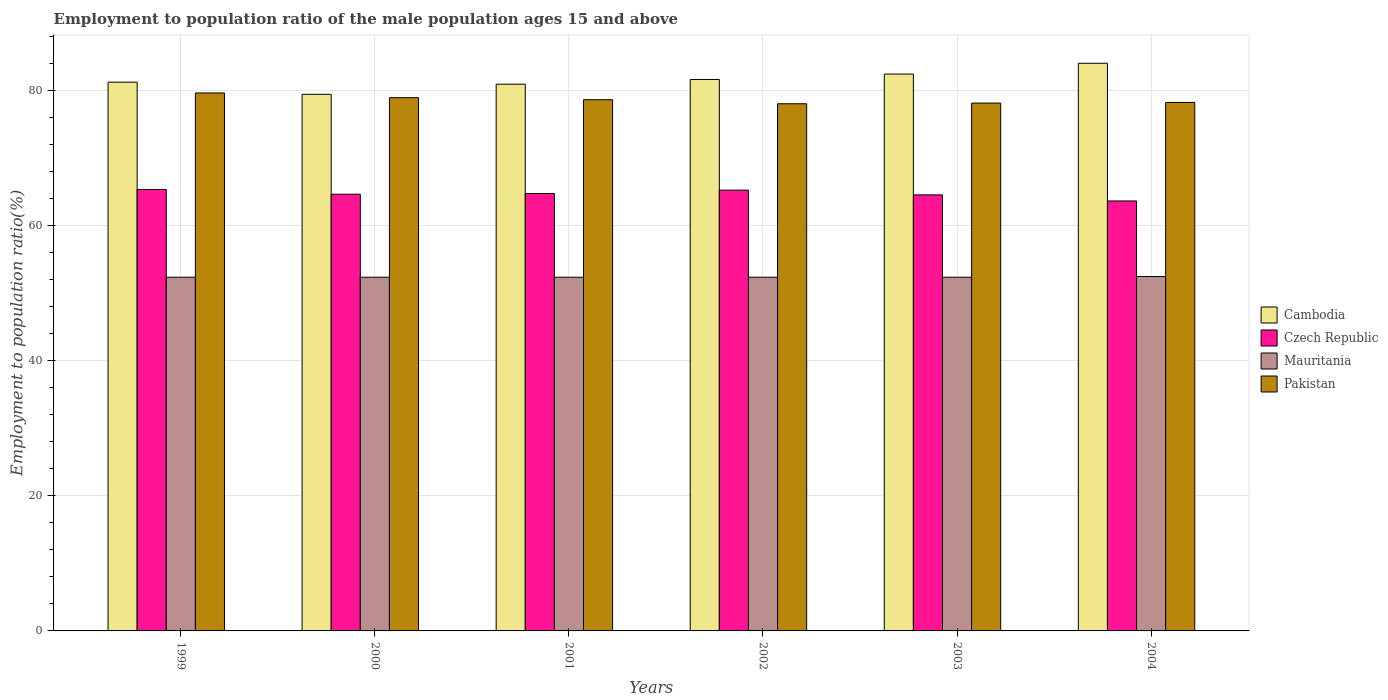Are the number of bars per tick equal to the number of legend labels?
Your answer should be compact. Yes. How many bars are there on the 4th tick from the left?
Your answer should be very brief. 4. In how many cases, is the number of bars for a given year not equal to the number of legend labels?
Give a very brief answer. 0. What is the employment to population ratio in Czech Republic in 2004?
Provide a short and direct response. 63.7. Across all years, what is the maximum employment to population ratio in Mauritania?
Offer a terse response. 52.5. Across all years, what is the minimum employment to population ratio in Cambodia?
Ensure brevity in your answer.  79.5. In which year was the employment to population ratio in Cambodia minimum?
Your response must be concise. 2000. What is the total employment to population ratio in Czech Republic in the graph?
Your answer should be compact. 388.5. What is the difference between the employment to population ratio in Cambodia in 2000 and that in 2003?
Keep it short and to the point. -3. What is the difference between the employment to population ratio in Mauritania in 2002 and the employment to population ratio in Cambodia in 1999?
Give a very brief answer. -28.9. What is the average employment to population ratio in Pakistan per year?
Your response must be concise. 78.67. In the year 2001, what is the difference between the employment to population ratio in Pakistan and employment to population ratio in Czech Republic?
Provide a succinct answer. 13.9. What is the ratio of the employment to population ratio in Czech Republic in 1999 to that in 2000?
Ensure brevity in your answer.  1.01. What is the difference between the highest and the second highest employment to population ratio in Cambodia?
Make the answer very short. 1.6. What is the difference between the highest and the lowest employment to population ratio in Pakistan?
Ensure brevity in your answer.  1.6. In how many years, is the employment to population ratio in Czech Republic greater than the average employment to population ratio in Czech Republic taken over all years?
Provide a succinct answer. 3. Is it the case that in every year, the sum of the employment to population ratio in Mauritania and employment to population ratio in Cambodia is greater than the sum of employment to population ratio in Pakistan and employment to population ratio in Czech Republic?
Your answer should be compact. Yes. What does the 1st bar from the left in 2004 represents?
Offer a terse response. Cambodia. What does the 2nd bar from the right in 1999 represents?
Your response must be concise. Mauritania. Is it the case that in every year, the sum of the employment to population ratio in Cambodia and employment to population ratio in Pakistan is greater than the employment to population ratio in Czech Republic?
Your answer should be compact. Yes. Are all the bars in the graph horizontal?
Provide a succinct answer. No. How many years are there in the graph?
Keep it short and to the point. 6. How are the legend labels stacked?
Make the answer very short. Vertical. What is the title of the graph?
Make the answer very short. Employment to population ratio of the male population ages 15 and above. What is the label or title of the Y-axis?
Offer a very short reply. Employment to population ratio(%). What is the Employment to population ratio(%) of Cambodia in 1999?
Your response must be concise. 81.3. What is the Employment to population ratio(%) of Czech Republic in 1999?
Make the answer very short. 65.4. What is the Employment to population ratio(%) of Mauritania in 1999?
Provide a succinct answer. 52.4. What is the Employment to population ratio(%) of Pakistan in 1999?
Keep it short and to the point. 79.7. What is the Employment to population ratio(%) of Cambodia in 2000?
Keep it short and to the point. 79.5. What is the Employment to population ratio(%) in Czech Republic in 2000?
Ensure brevity in your answer.  64.7. What is the Employment to population ratio(%) in Mauritania in 2000?
Provide a short and direct response. 52.4. What is the Employment to population ratio(%) of Pakistan in 2000?
Offer a terse response. 79. What is the Employment to population ratio(%) of Czech Republic in 2001?
Make the answer very short. 64.8. What is the Employment to population ratio(%) in Mauritania in 2001?
Your answer should be very brief. 52.4. What is the Employment to population ratio(%) of Pakistan in 2001?
Make the answer very short. 78.7. What is the Employment to population ratio(%) in Cambodia in 2002?
Your answer should be compact. 81.7. What is the Employment to population ratio(%) of Czech Republic in 2002?
Your response must be concise. 65.3. What is the Employment to population ratio(%) in Mauritania in 2002?
Your answer should be compact. 52.4. What is the Employment to population ratio(%) of Pakistan in 2002?
Ensure brevity in your answer.  78.1. What is the Employment to population ratio(%) of Cambodia in 2003?
Make the answer very short. 82.5. What is the Employment to population ratio(%) in Czech Republic in 2003?
Provide a succinct answer. 64.6. What is the Employment to population ratio(%) in Mauritania in 2003?
Provide a succinct answer. 52.4. What is the Employment to population ratio(%) of Pakistan in 2003?
Offer a terse response. 78.2. What is the Employment to population ratio(%) of Cambodia in 2004?
Provide a short and direct response. 84.1. What is the Employment to population ratio(%) in Czech Republic in 2004?
Your answer should be compact. 63.7. What is the Employment to population ratio(%) of Mauritania in 2004?
Keep it short and to the point. 52.5. What is the Employment to population ratio(%) in Pakistan in 2004?
Give a very brief answer. 78.3. Across all years, what is the maximum Employment to population ratio(%) of Cambodia?
Make the answer very short. 84.1. Across all years, what is the maximum Employment to population ratio(%) of Czech Republic?
Give a very brief answer. 65.4. Across all years, what is the maximum Employment to population ratio(%) of Mauritania?
Your answer should be compact. 52.5. Across all years, what is the maximum Employment to population ratio(%) in Pakistan?
Ensure brevity in your answer.  79.7. Across all years, what is the minimum Employment to population ratio(%) of Cambodia?
Your response must be concise. 79.5. Across all years, what is the minimum Employment to population ratio(%) of Czech Republic?
Your response must be concise. 63.7. Across all years, what is the minimum Employment to population ratio(%) of Mauritania?
Your answer should be very brief. 52.4. Across all years, what is the minimum Employment to population ratio(%) in Pakistan?
Offer a very short reply. 78.1. What is the total Employment to population ratio(%) in Cambodia in the graph?
Provide a succinct answer. 490.1. What is the total Employment to population ratio(%) of Czech Republic in the graph?
Make the answer very short. 388.5. What is the total Employment to population ratio(%) of Mauritania in the graph?
Offer a very short reply. 314.5. What is the total Employment to population ratio(%) in Pakistan in the graph?
Your response must be concise. 472. What is the difference between the Employment to population ratio(%) of Cambodia in 1999 and that in 2000?
Your response must be concise. 1.8. What is the difference between the Employment to population ratio(%) of Czech Republic in 1999 and that in 2000?
Give a very brief answer. 0.7. What is the difference between the Employment to population ratio(%) in Czech Republic in 1999 and that in 2002?
Ensure brevity in your answer.  0.1. What is the difference between the Employment to population ratio(%) of Mauritania in 1999 and that in 2002?
Make the answer very short. 0. What is the difference between the Employment to population ratio(%) in Pakistan in 1999 and that in 2002?
Your answer should be compact. 1.6. What is the difference between the Employment to population ratio(%) in Cambodia in 1999 and that in 2003?
Ensure brevity in your answer.  -1.2. What is the difference between the Employment to population ratio(%) of Cambodia in 1999 and that in 2004?
Your response must be concise. -2.8. What is the difference between the Employment to population ratio(%) in Cambodia in 2000 and that in 2001?
Offer a terse response. -1.5. What is the difference between the Employment to population ratio(%) of Czech Republic in 2000 and that in 2001?
Give a very brief answer. -0.1. What is the difference between the Employment to population ratio(%) of Mauritania in 2000 and that in 2001?
Your answer should be very brief. 0. What is the difference between the Employment to population ratio(%) in Czech Republic in 2000 and that in 2002?
Keep it short and to the point. -0.6. What is the difference between the Employment to population ratio(%) of Cambodia in 2000 and that in 2003?
Your answer should be compact. -3. What is the difference between the Employment to population ratio(%) in Pakistan in 2000 and that in 2003?
Offer a terse response. 0.8. What is the difference between the Employment to population ratio(%) in Pakistan in 2000 and that in 2004?
Offer a terse response. 0.7. What is the difference between the Employment to population ratio(%) of Pakistan in 2001 and that in 2002?
Keep it short and to the point. 0.6. What is the difference between the Employment to population ratio(%) of Cambodia in 2001 and that in 2003?
Your response must be concise. -1.5. What is the difference between the Employment to population ratio(%) in Czech Republic in 2001 and that in 2003?
Offer a terse response. 0.2. What is the difference between the Employment to population ratio(%) of Mauritania in 2001 and that in 2003?
Keep it short and to the point. 0. What is the difference between the Employment to population ratio(%) in Cambodia in 2001 and that in 2004?
Offer a terse response. -3.1. What is the difference between the Employment to population ratio(%) of Czech Republic in 2001 and that in 2004?
Provide a short and direct response. 1.1. What is the difference between the Employment to population ratio(%) in Cambodia in 2002 and that in 2003?
Your answer should be very brief. -0.8. What is the difference between the Employment to population ratio(%) in Czech Republic in 2002 and that in 2003?
Provide a succinct answer. 0.7. What is the difference between the Employment to population ratio(%) in Cambodia in 2003 and that in 2004?
Give a very brief answer. -1.6. What is the difference between the Employment to population ratio(%) in Czech Republic in 2003 and that in 2004?
Your response must be concise. 0.9. What is the difference between the Employment to population ratio(%) of Mauritania in 2003 and that in 2004?
Offer a very short reply. -0.1. What is the difference between the Employment to population ratio(%) in Cambodia in 1999 and the Employment to population ratio(%) in Mauritania in 2000?
Make the answer very short. 28.9. What is the difference between the Employment to population ratio(%) in Cambodia in 1999 and the Employment to population ratio(%) in Pakistan in 2000?
Give a very brief answer. 2.3. What is the difference between the Employment to population ratio(%) of Czech Republic in 1999 and the Employment to population ratio(%) of Pakistan in 2000?
Offer a terse response. -13.6. What is the difference between the Employment to population ratio(%) of Mauritania in 1999 and the Employment to population ratio(%) of Pakistan in 2000?
Your answer should be compact. -26.6. What is the difference between the Employment to population ratio(%) of Cambodia in 1999 and the Employment to population ratio(%) of Mauritania in 2001?
Keep it short and to the point. 28.9. What is the difference between the Employment to population ratio(%) of Czech Republic in 1999 and the Employment to population ratio(%) of Mauritania in 2001?
Make the answer very short. 13. What is the difference between the Employment to population ratio(%) of Czech Republic in 1999 and the Employment to population ratio(%) of Pakistan in 2001?
Provide a short and direct response. -13.3. What is the difference between the Employment to population ratio(%) in Mauritania in 1999 and the Employment to population ratio(%) in Pakistan in 2001?
Give a very brief answer. -26.3. What is the difference between the Employment to population ratio(%) in Cambodia in 1999 and the Employment to population ratio(%) in Czech Republic in 2002?
Your response must be concise. 16. What is the difference between the Employment to population ratio(%) of Cambodia in 1999 and the Employment to population ratio(%) of Mauritania in 2002?
Offer a terse response. 28.9. What is the difference between the Employment to population ratio(%) in Mauritania in 1999 and the Employment to population ratio(%) in Pakistan in 2002?
Provide a succinct answer. -25.7. What is the difference between the Employment to population ratio(%) of Cambodia in 1999 and the Employment to population ratio(%) of Mauritania in 2003?
Provide a short and direct response. 28.9. What is the difference between the Employment to population ratio(%) in Cambodia in 1999 and the Employment to population ratio(%) in Pakistan in 2003?
Ensure brevity in your answer.  3.1. What is the difference between the Employment to population ratio(%) in Czech Republic in 1999 and the Employment to population ratio(%) in Mauritania in 2003?
Your response must be concise. 13. What is the difference between the Employment to population ratio(%) of Czech Republic in 1999 and the Employment to population ratio(%) of Pakistan in 2003?
Provide a succinct answer. -12.8. What is the difference between the Employment to population ratio(%) of Mauritania in 1999 and the Employment to population ratio(%) of Pakistan in 2003?
Provide a short and direct response. -25.8. What is the difference between the Employment to population ratio(%) in Cambodia in 1999 and the Employment to population ratio(%) in Czech Republic in 2004?
Your answer should be very brief. 17.6. What is the difference between the Employment to population ratio(%) in Cambodia in 1999 and the Employment to population ratio(%) in Mauritania in 2004?
Your response must be concise. 28.8. What is the difference between the Employment to population ratio(%) of Czech Republic in 1999 and the Employment to population ratio(%) of Mauritania in 2004?
Your response must be concise. 12.9. What is the difference between the Employment to population ratio(%) of Czech Republic in 1999 and the Employment to population ratio(%) of Pakistan in 2004?
Give a very brief answer. -12.9. What is the difference between the Employment to population ratio(%) in Mauritania in 1999 and the Employment to population ratio(%) in Pakistan in 2004?
Make the answer very short. -25.9. What is the difference between the Employment to population ratio(%) in Cambodia in 2000 and the Employment to population ratio(%) in Czech Republic in 2001?
Provide a short and direct response. 14.7. What is the difference between the Employment to population ratio(%) in Cambodia in 2000 and the Employment to population ratio(%) in Mauritania in 2001?
Give a very brief answer. 27.1. What is the difference between the Employment to population ratio(%) in Mauritania in 2000 and the Employment to population ratio(%) in Pakistan in 2001?
Provide a short and direct response. -26.3. What is the difference between the Employment to population ratio(%) of Cambodia in 2000 and the Employment to population ratio(%) of Mauritania in 2002?
Provide a succinct answer. 27.1. What is the difference between the Employment to population ratio(%) of Cambodia in 2000 and the Employment to population ratio(%) of Pakistan in 2002?
Your answer should be very brief. 1.4. What is the difference between the Employment to population ratio(%) in Czech Republic in 2000 and the Employment to population ratio(%) in Mauritania in 2002?
Your response must be concise. 12.3. What is the difference between the Employment to population ratio(%) of Mauritania in 2000 and the Employment to population ratio(%) of Pakistan in 2002?
Offer a terse response. -25.7. What is the difference between the Employment to population ratio(%) of Cambodia in 2000 and the Employment to population ratio(%) of Czech Republic in 2003?
Offer a very short reply. 14.9. What is the difference between the Employment to population ratio(%) of Cambodia in 2000 and the Employment to population ratio(%) of Mauritania in 2003?
Make the answer very short. 27.1. What is the difference between the Employment to population ratio(%) in Cambodia in 2000 and the Employment to population ratio(%) in Pakistan in 2003?
Provide a succinct answer. 1.3. What is the difference between the Employment to population ratio(%) in Mauritania in 2000 and the Employment to population ratio(%) in Pakistan in 2003?
Your response must be concise. -25.8. What is the difference between the Employment to population ratio(%) of Cambodia in 2000 and the Employment to population ratio(%) of Czech Republic in 2004?
Provide a short and direct response. 15.8. What is the difference between the Employment to population ratio(%) in Czech Republic in 2000 and the Employment to population ratio(%) in Mauritania in 2004?
Your answer should be very brief. 12.2. What is the difference between the Employment to population ratio(%) of Mauritania in 2000 and the Employment to population ratio(%) of Pakistan in 2004?
Your answer should be compact. -25.9. What is the difference between the Employment to population ratio(%) of Cambodia in 2001 and the Employment to population ratio(%) of Czech Republic in 2002?
Your answer should be very brief. 15.7. What is the difference between the Employment to population ratio(%) of Cambodia in 2001 and the Employment to population ratio(%) of Mauritania in 2002?
Your answer should be compact. 28.6. What is the difference between the Employment to population ratio(%) of Cambodia in 2001 and the Employment to population ratio(%) of Pakistan in 2002?
Provide a succinct answer. 2.9. What is the difference between the Employment to population ratio(%) of Czech Republic in 2001 and the Employment to population ratio(%) of Pakistan in 2002?
Provide a succinct answer. -13.3. What is the difference between the Employment to population ratio(%) in Mauritania in 2001 and the Employment to population ratio(%) in Pakistan in 2002?
Your response must be concise. -25.7. What is the difference between the Employment to population ratio(%) in Cambodia in 2001 and the Employment to population ratio(%) in Czech Republic in 2003?
Make the answer very short. 16.4. What is the difference between the Employment to population ratio(%) of Cambodia in 2001 and the Employment to population ratio(%) of Mauritania in 2003?
Provide a succinct answer. 28.6. What is the difference between the Employment to population ratio(%) of Cambodia in 2001 and the Employment to population ratio(%) of Pakistan in 2003?
Provide a short and direct response. 2.8. What is the difference between the Employment to population ratio(%) of Czech Republic in 2001 and the Employment to population ratio(%) of Pakistan in 2003?
Provide a succinct answer. -13.4. What is the difference between the Employment to population ratio(%) of Mauritania in 2001 and the Employment to population ratio(%) of Pakistan in 2003?
Give a very brief answer. -25.8. What is the difference between the Employment to population ratio(%) of Cambodia in 2001 and the Employment to population ratio(%) of Czech Republic in 2004?
Your answer should be compact. 17.3. What is the difference between the Employment to population ratio(%) in Cambodia in 2001 and the Employment to population ratio(%) in Mauritania in 2004?
Your response must be concise. 28.5. What is the difference between the Employment to population ratio(%) in Czech Republic in 2001 and the Employment to population ratio(%) in Mauritania in 2004?
Provide a short and direct response. 12.3. What is the difference between the Employment to population ratio(%) of Mauritania in 2001 and the Employment to population ratio(%) of Pakistan in 2004?
Your response must be concise. -25.9. What is the difference between the Employment to population ratio(%) in Cambodia in 2002 and the Employment to population ratio(%) in Mauritania in 2003?
Make the answer very short. 29.3. What is the difference between the Employment to population ratio(%) in Czech Republic in 2002 and the Employment to population ratio(%) in Pakistan in 2003?
Ensure brevity in your answer.  -12.9. What is the difference between the Employment to population ratio(%) in Mauritania in 2002 and the Employment to population ratio(%) in Pakistan in 2003?
Give a very brief answer. -25.8. What is the difference between the Employment to population ratio(%) in Cambodia in 2002 and the Employment to population ratio(%) in Czech Republic in 2004?
Provide a succinct answer. 18. What is the difference between the Employment to population ratio(%) in Cambodia in 2002 and the Employment to population ratio(%) in Mauritania in 2004?
Give a very brief answer. 29.2. What is the difference between the Employment to population ratio(%) in Cambodia in 2002 and the Employment to population ratio(%) in Pakistan in 2004?
Offer a very short reply. 3.4. What is the difference between the Employment to population ratio(%) of Mauritania in 2002 and the Employment to population ratio(%) of Pakistan in 2004?
Make the answer very short. -25.9. What is the difference between the Employment to population ratio(%) in Cambodia in 2003 and the Employment to population ratio(%) in Mauritania in 2004?
Make the answer very short. 30. What is the difference between the Employment to population ratio(%) in Czech Republic in 2003 and the Employment to population ratio(%) in Mauritania in 2004?
Your answer should be compact. 12.1. What is the difference between the Employment to population ratio(%) of Czech Republic in 2003 and the Employment to population ratio(%) of Pakistan in 2004?
Your answer should be compact. -13.7. What is the difference between the Employment to population ratio(%) in Mauritania in 2003 and the Employment to population ratio(%) in Pakistan in 2004?
Make the answer very short. -25.9. What is the average Employment to population ratio(%) of Cambodia per year?
Provide a succinct answer. 81.68. What is the average Employment to population ratio(%) of Czech Republic per year?
Keep it short and to the point. 64.75. What is the average Employment to population ratio(%) of Mauritania per year?
Ensure brevity in your answer.  52.42. What is the average Employment to population ratio(%) of Pakistan per year?
Offer a terse response. 78.67. In the year 1999, what is the difference between the Employment to population ratio(%) of Cambodia and Employment to population ratio(%) of Czech Republic?
Provide a short and direct response. 15.9. In the year 1999, what is the difference between the Employment to population ratio(%) of Cambodia and Employment to population ratio(%) of Mauritania?
Offer a terse response. 28.9. In the year 1999, what is the difference between the Employment to population ratio(%) of Czech Republic and Employment to population ratio(%) of Pakistan?
Provide a succinct answer. -14.3. In the year 1999, what is the difference between the Employment to population ratio(%) in Mauritania and Employment to population ratio(%) in Pakistan?
Keep it short and to the point. -27.3. In the year 2000, what is the difference between the Employment to population ratio(%) of Cambodia and Employment to population ratio(%) of Mauritania?
Your answer should be very brief. 27.1. In the year 2000, what is the difference between the Employment to population ratio(%) in Czech Republic and Employment to population ratio(%) in Mauritania?
Make the answer very short. 12.3. In the year 2000, what is the difference between the Employment to population ratio(%) in Czech Republic and Employment to population ratio(%) in Pakistan?
Make the answer very short. -14.3. In the year 2000, what is the difference between the Employment to population ratio(%) in Mauritania and Employment to population ratio(%) in Pakistan?
Your answer should be compact. -26.6. In the year 2001, what is the difference between the Employment to population ratio(%) in Cambodia and Employment to population ratio(%) in Czech Republic?
Your answer should be compact. 16.2. In the year 2001, what is the difference between the Employment to population ratio(%) in Cambodia and Employment to population ratio(%) in Mauritania?
Your answer should be very brief. 28.6. In the year 2001, what is the difference between the Employment to population ratio(%) of Cambodia and Employment to population ratio(%) of Pakistan?
Give a very brief answer. 2.3. In the year 2001, what is the difference between the Employment to population ratio(%) of Czech Republic and Employment to population ratio(%) of Mauritania?
Your response must be concise. 12.4. In the year 2001, what is the difference between the Employment to population ratio(%) of Mauritania and Employment to population ratio(%) of Pakistan?
Make the answer very short. -26.3. In the year 2002, what is the difference between the Employment to population ratio(%) of Cambodia and Employment to population ratio(%) of Czech Republic?
Give a very brief answer. 16.4. In the year 2002, what is the difference between the Employment to population ratio(%) in Cambodia and Employment to population ratio(%) in Mauritania?
Offer a very short reply. 29.3. In the year 2002, what is the difference between the Employment to population ratio(%) in Czech Republic and Employment to population ratio(%) in Pakistan?
Your response must be concise. -12.8. In the year 2002, what is the difference between the Employment to population ratio(%) in Mauritania and Employment to population ratio(%) in Pakistan?
Ensure brevity in your answer.  -25.7. In the year 2003, what is the difference between the Employment to population ratio(%) in Cambodia and Employment to population ratio(%) in Czech Republic?
Make the answer very short. 17.9. In the year 2003, what is the difference between the Employment to population ratio(%) in Cambodia and Employment to population ratio(%) in Mauritania?
Make the answer very short. 30.1. In the year 2003, what is the difference between the Employment to population ratio(%) of Czech Republic and Employment to population ratio(%) of Pakistan?
Provide a succinct answer. -13.6. In the year 2003, what is the difference between the Employment to population ratio(%) of Mauritania and Employment to population ratio(%) of Pakistan?
Make the answer very short. -25.8. In the year 2004, what is the difference between the Employment to population ratio(%) in Cambodia and Employment to population ratio(%) in Czech Republic?
Your answer should be compact. 20.4. In the year 2004, what is the difference between the Employment to population ratio(%) of Cambodia and Employment to population ratio(%) of Mauritania?
Your answer should be very brief. 31.6. In the year 2004, what is the difference between the Employment to population ratio(%) in Cambodia and Employment to population ratio(%) in Pakistan?
Keep it short and to the point. 5.8. In the year 2004, what is the difference between the Employment to population ratio(%) of Czech Republic and Employment to population ratio(%) of Pakistan?
Give a very brief answer. -14.6. In the year 2004, what is the difference between the Employment to population ratio(%) of Mauritania and Employment to population ratio(%) of Pakistan?
Keep it short and to the point. -25.8. What is the ratio of the Employment to population ratio(%) in Cambodia in 1999 to that in 2000?
Keep it short and to the point. 1.02. What is the ratio of the Employment to population ratio(%) of Czech Republic in 1999 to that in 2000?
Your answer should be compact. 1.01. What is the ratio of the Employment to population ratio(%) in Pakistan in 1999 to that in 2000?
Provide a short and direct response. 1.01. What is the ratio of the Employment to population ratio(%) in Czech Republic in 1999 to that in 2001?
Offer a terse response. 1.01. What is the ratio of the Employment to population ratio(%) of Mauritania in 1999 to that in 2001?
Keep it short and to the point. 1. What is the ratio of the Employment to population ratio(%) in Pakistan in 1999 to that in 2001?
Your answer should be compact. 1.01. What is the ratio of the Employment to population ratio(%) of Mauritania in 1999 to that in 2002?
Your response must be concise. 1. What is the ratio of the Employment to population ratio(%) in Pakistan in 1999 to that in 2002?
Your response must be concise. 1.02. What is the ratio of the Employment to population ratio(%) in Cambodia in 1999 to that in 2003?
Your answer should be compact. 0.99. What is the ratio of the Employment to population ratio(%) in Czech Republic in 1999 to that in 2003?
Make the answer very short. 1.01. What is the ratio of the Employment to population ratio(%) in Mauritania in 1999 to that in 2003?
Ensure brevity in your answer.  1. What is the ratio of the Employment to population ratio(%) of Pakistan in 1999 to that in 2003?
Give a very brief answer. 1.02. What is the ratio of the Employment to population ratio(%) of Cambodia in 1999 to that in 2004?
Offer a very short reply. 0.97. What is the ratio of the Employment to population ratio(%) of Czech Republic in 1999 to that in 2004?
Your answer should be compact. 1.03. What is the ratio of the Employment to population ratio(%) in Mauritania in 1999 to that in 2004?
Make the answer very short. 1. What is the ratio of the Employment to population ratio(%) of Pakistan in 1999 to that in 2004?
Give a very brief answer. 1.02. What is the ratio of the Employment to population ratio(%) of Cambodia in 2000 to that in 2001?
Your response must be concise. 0.98. What is the ratio of the Employment to population ratio(%) in Czech Republic in 2000 to that in 2001?
Offer a terse response. 1. What is the ratio of the Employment to population ratio(%) in Mauritania in 2000 to that in 2001?
Provide a succinct answer. 1. What is the ratio of the Employment to population ratio(%) of Cambodia in 2000 to that in 2002?
Offer a terse response. 0.97. What is the ratio of the Employment to population ratio(%) in Czech Republic in 2000 to that in 2002?
Offer a very short reply. 0.99. What is the ratio of the Employment to population ratio(%) of Pakistan in 2000 to that in 2002?
Give a very brief answer. 1.01. What is the ratio of the Employment to population ratio(%) in Cambodia in 2000 to that in 2003?
Provide a succinct answer. 0.96. What is the ratio of the Employment to population ratio(%) of Pakistan in 2000 to that in 2003?
Keep it short and to the point. 1.01. What is the ratio of the Employment to population ratio(%) of Cambodia in 2000 to that in 2004?
Provide a short and direct response. 0.95. What is the ratio of the Employment to population ratio(%) of Czech Republic in 2000 to that in 2004?
Give a very brief answer. 1.02. What is the ratio of the Employment to population ratio(%) in Mauritania in 2000 to that in 2004?
Offer a terse response. 1. What is the ratio of the Employment to population ratio(%) in Pakistan in 2000 to that in 2004?
Make the answer very short. 1.01. What is the ratio of the Employment to population ratio(%) in Cambodia in 2001 to that in 2002?
Your response must be concise. 0.99. What is the ratio of the Employment to population ratio(%) of Czech Republic in 2001 to that in 2002?
Offer a terse response. 0.99. What is the ratio of the Employment to population ratio(%) in Pakistan in 2001 to that in 2002?
Keep it short and to the point. 1.01. What is the ratio of the Employment to population ratio(%) in Cambodia in 2001 to that in 2003?
Give a very brief answer. 0.98. What is the ratio of the Employment to population ratio(%) in Czech Republic in 2001 to that in 2003?
Your answer should be very brief. 1. What is the ratio of the Employment to population ratio(%) in Mauritania in 2001 to that in 2003?
Your answer should be very brief. 1. What is the ratio of the Employment to population ratio(%) in Pakistan in 2001 to that in 2003?
Offer a very short reply. 1.01. What is the ratio of the Employment to population ratio(%) in Cambodia in 2001 to that in 2004?
Offer a terse response. 0.96. What is the ratio of the Employment to population ratio(%) in Czech Republic in 2001 to that in 2004?
Your answer should be compact. 1.02. What is the ratio of the Employment to population ratio(%) in Mauritania in 2001 to that in 2004?
Give a very brief answer. 1. What is the ratio of the Employment to population ratio(%) of Pakistan in 2001 to that in 2004?
Provide a succinct answer. 1.01. What is the ratio of the Employment to population ratio(%) in Cambodia in 2002 to that in 2003?
Provide a succinct answer. 0.99. What is the ratio of the Employment to population ratio(%) in Czech Republic in 2002 to that in 2003?
Give a very brief answer. 1.01. What is the ratio of the Employment to population ratio(%) of Pakistan in 2002 to that in 2003?
Offer a terse response. 1. What is the ratio of the Employment to population ratio(%) in Cambodia in 2002 to that in 2004?
Offer a very short reply. 0.97. What is the ratio of the Employment to population ratio(%) of Czech Republic in 2002 to that in 2004?
Ensure brevity in your answer.  1.03. What is the ratio of the Employment to population ratio(%) of Mauritania in 2002 to that in 2004?
Your response must be concise. 1. What is the ratio of the Employment to population ratio(%) of Czech Republic in 2003 to that in 2004?
Give a very brief answer. 1.01. What is the ratio of the Employment to population ratio(%) of Pakistan in 2003 to that in 2004?
Provide a short and direct response. 1. What is the difference between the highest and the second highest Employment to population ratio(%) of Cambodia?
Offer a very short reply. 1.6. What is the difference between the highest and the second highest Employment to population ratio(%) in Czech Republic?
Offer a terse response. 0.1. What is the difference between the highest and the second highest Employment to population ratio(%) in Mauritania?
Make the answer very short. 0.1. What is the difference between the highest and the second highest Employment to population ratio(%) of Pakistan?
Give a very brief answer. 0.7. What is the difference between the highest and the lowest Employment to population ratio(%) of Cambodia?
Keep it short and to the point. 4.6. What is the difference between the highest and the lowest Employment to population ratio(%) in Mauritania?
Your answer should be compact. 0.1. 